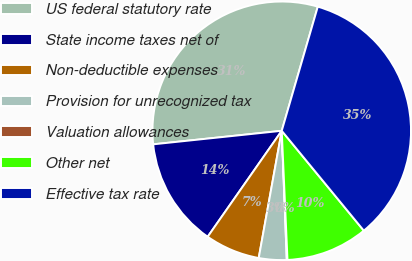<chart> <loc_0><loc_0><loc_500><loc_500><pie_chart><fcel>US federal statutory rate<fcel>State income taxes net of<fcel>Non-deductible expenses<fcel>Provision for unrecognized tax<fcel>Valuation allowances<fcel>Other net<fcel>Effective tax rate<nl><fcel>31.17%<fcel>13.62%<fcel>6.86%<fcel>3.47%<fcel>0.09%<fcel>10.24%<fcel>34.55%<nl></chart> 